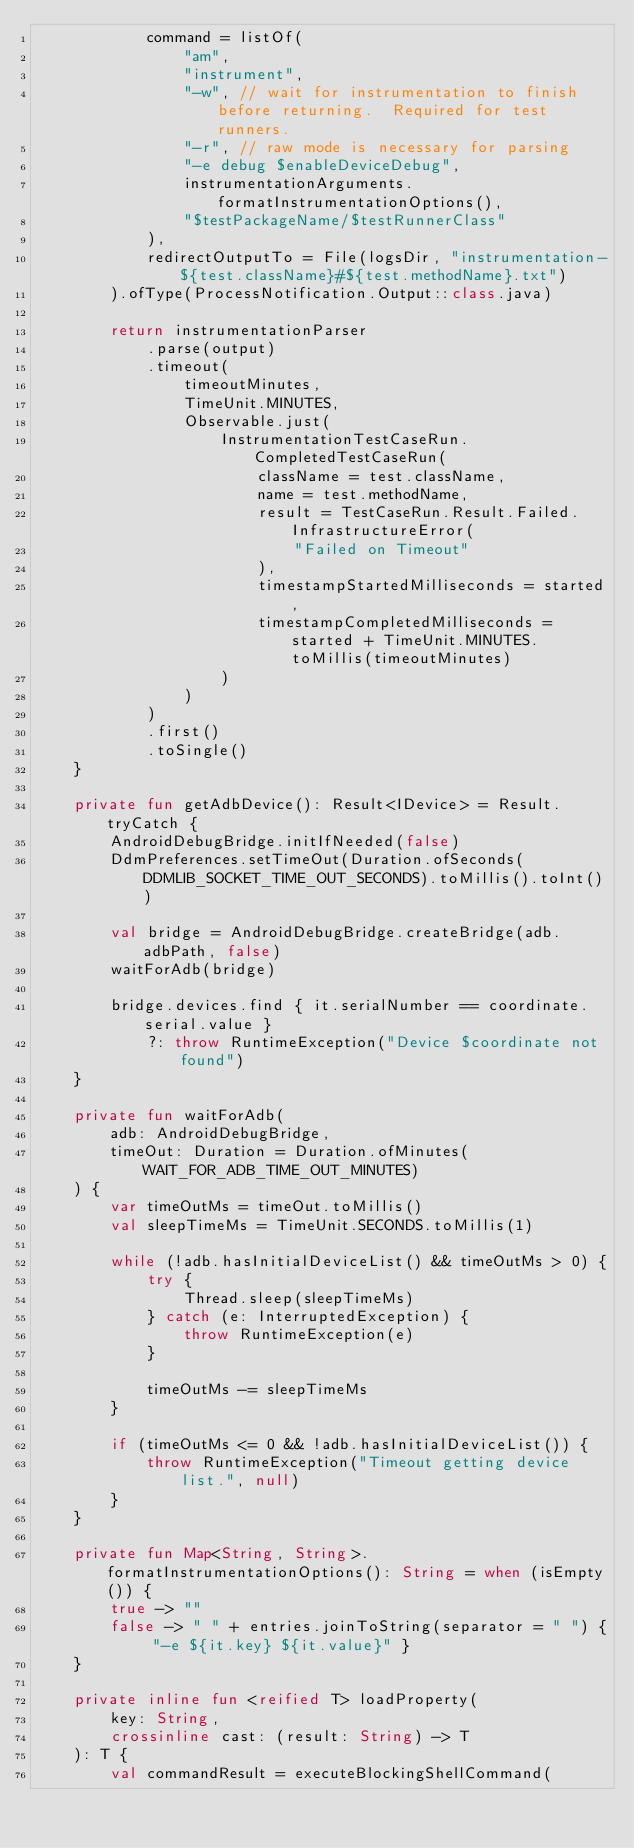<code> <loc_0><loc_0><loc_500><loc_500><_Kotlin_>            command = listOf(
                "am",
                "instrument",
                "-w", // wait for instrumentation to finish before returning.  Required for test runners.
                "-r", // raw mode is necessary for parsing
                "-e debug $enableDeviceDebug",
                instrumentationArguments.formatInstrumentationOptions(),
                "$testPackageName/$testRunnerClass"
            ),
            redirectOutputTo = File(logsDir, "instrumentation-${test.className}#${test.methodName}.txt")
        ).ofType(ProcessNotification.Output::class.java)

        return instrumentationParser
            .parse(output)
            .timeout(
                timeoutMinutes,
                TimeUnit.MINUTES,
                Observable.just(
                    InstrumentationTestCaseRun.CompletedTestCaseRun(
                        className = test.className,
                        name = test.methodName,
                        result = TestCaseRun.Result.Failed.InfrastructureError(
                            "Failed on Timeout"
                        ),
                        timestampStartedMilliseconds = started,
                        timestampCompletedMilliseconds = started + TimeUnit.MINUTES.toMillis(timeoutMinutes)
                    )
                )
            )
            .first()
            .toSingle()
    }

    private fun getAdbDevice(): Result<IDevice> = Result.tryCatch {
        AndroidDebugBridge.initIfNeeded(false)
        DdmPreferences.setTimeOut(Duration.ofSeconds(DDMLIB_SOCKET_TIME_OUT_SECONDS).toMillis().toInt())

        val bridge = AndroidDebugBridge.createBridge(adb.adbPath, false)
        waitForAdb(bridge)

        bridge.devices.find { it.serialNumber == coordinate.serial.value }
            ?: throw RuntimeException("Device $coordinate not found")
    }

    private fun waitForAdb(
        adb: AndroidDebugBridge,
        timeOut: Duration = Duration.ofMinutes(WAIT_FOR_ADB_TIME_OUT_MINUTES)
    ) {
        var timeOutMs = timeOut.toMillis()
        val sleepTimeMs = TimeUnit.SECONDS.toMillis(1)

        while (!adb.hasInitialDeviceList() && timeOutMs > 0) {
            try {
                Thread.sleep(sleepTimeMs)
            } catch (e: InterruptedException) {
                throw RuntimeException(e)
            }

            timeOutMs -= sleepTimeMs
        }

        if (timeOutMs <= 0 && !adb.hasInitialDeviceList()) {
            throw RuntimeException("Timeout getting device list.", null)
        }
    }

    private fun Map<String, String>.formatInstrumentationOptions(): String = when (isEmpty()) {
        true -> ""
        false -> " " + entries.joinToString(separator = " ") { "-e ${it.key} ${it.value}" }
    }

    private inline fun <reified T> loadProperty(
        key: String,
        crossinline cast: (result: String) -> T
    ): T {
        val commandResult = executeBlockingShellCommand(</code> 